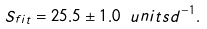<formula> <loc_0><loc_0><loc_500><loc_500>S _ { f i t } = 2 5 . 5 \pm 1 . 0 \ u n i t s { d ^ { - 1 } } .</formula> 